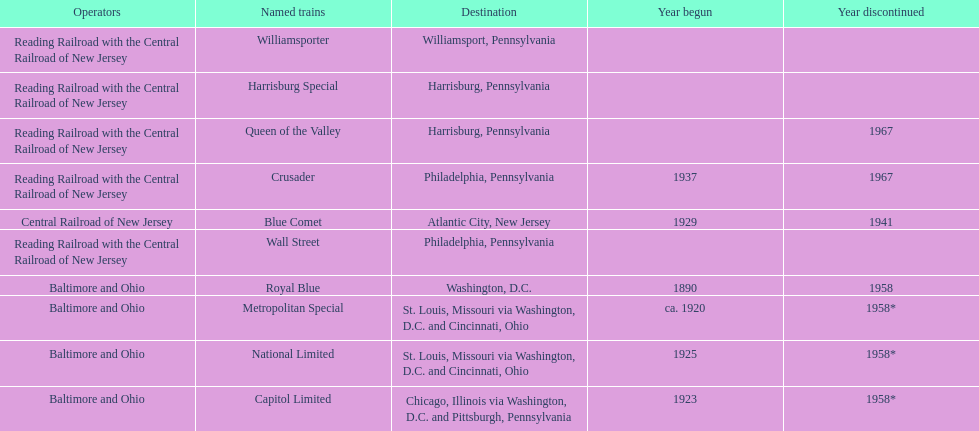What is the total number of year begun? 6. 